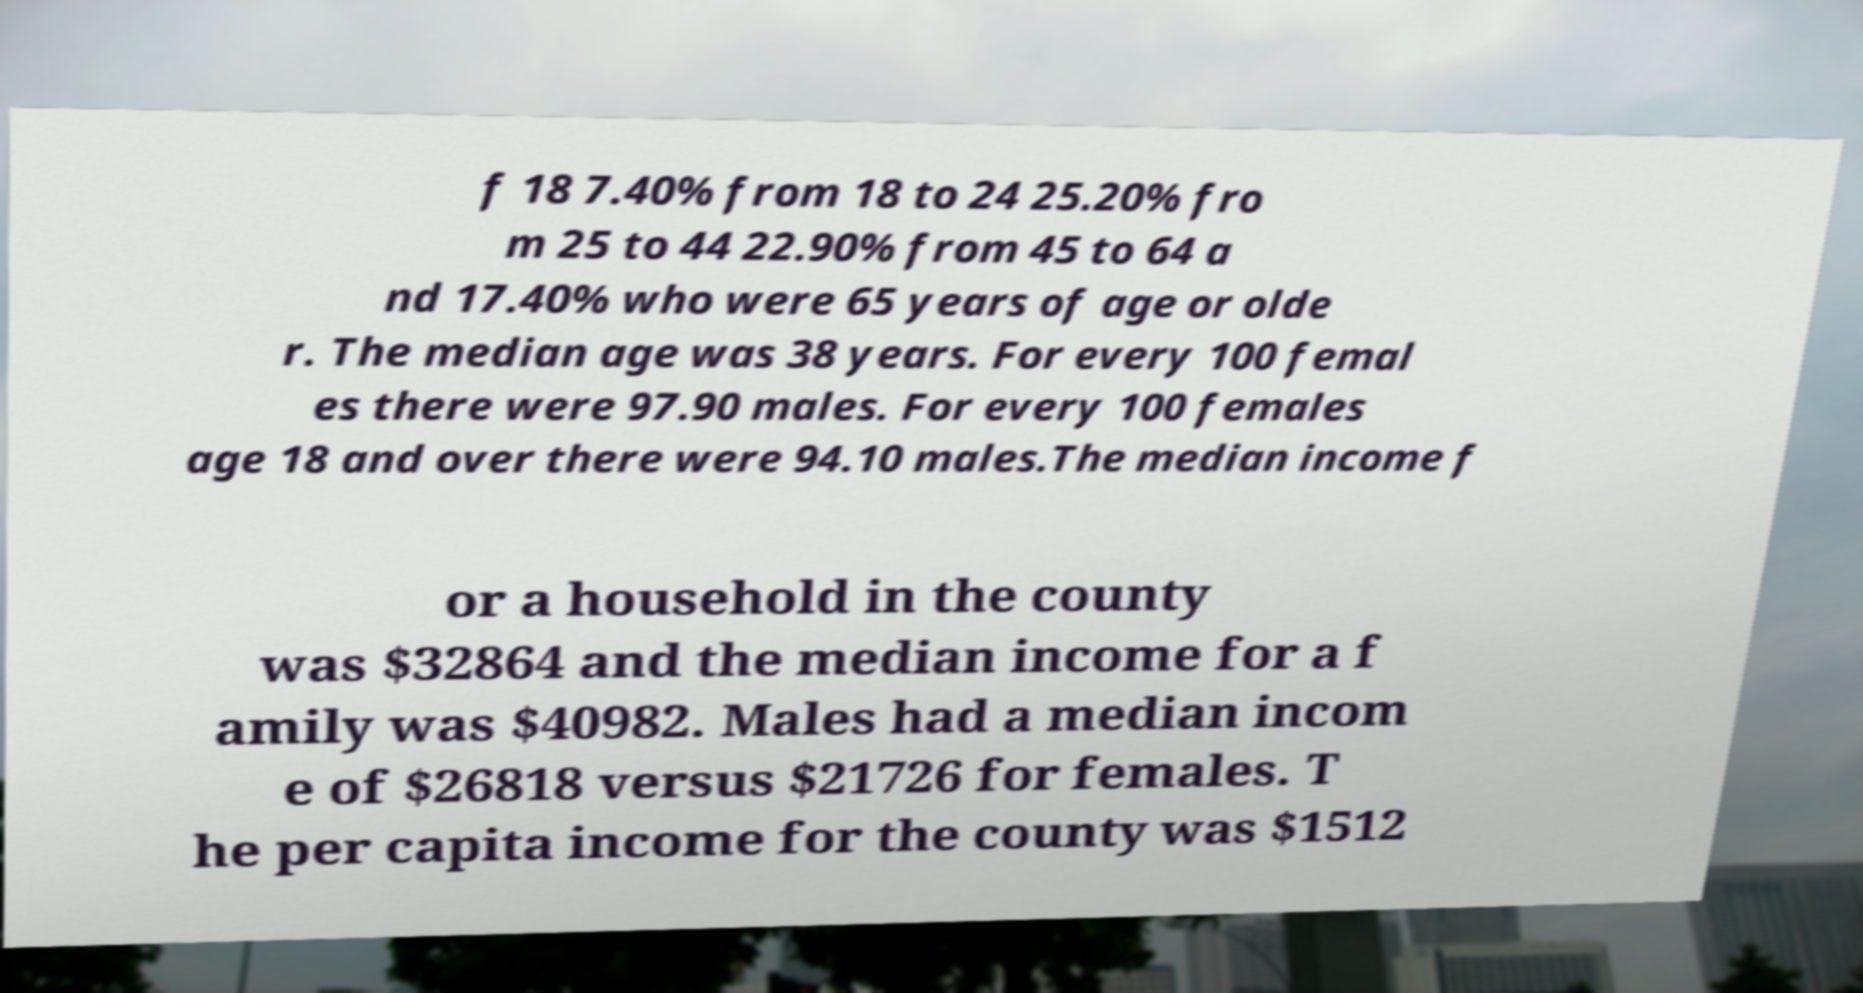For documentation purposes, I need the text within this image transcribed. Could you provide that? f 18 7.40% from 18 to 24 25.20% fro m 25 to 44 22.90% from 45 to 64 a nd 17.40% who were 65 years of age or olde r. The median age was 38 years. For every 100 femal es there were 97.90 males. For every 100 females age 18 and over there were 94.10 males.The median income f or a household in the county was $32864 and the median income for a f amily was $40982. Males had a median incom e of $26818 versus $21726 for females. T he per capita income for the county was $1512 